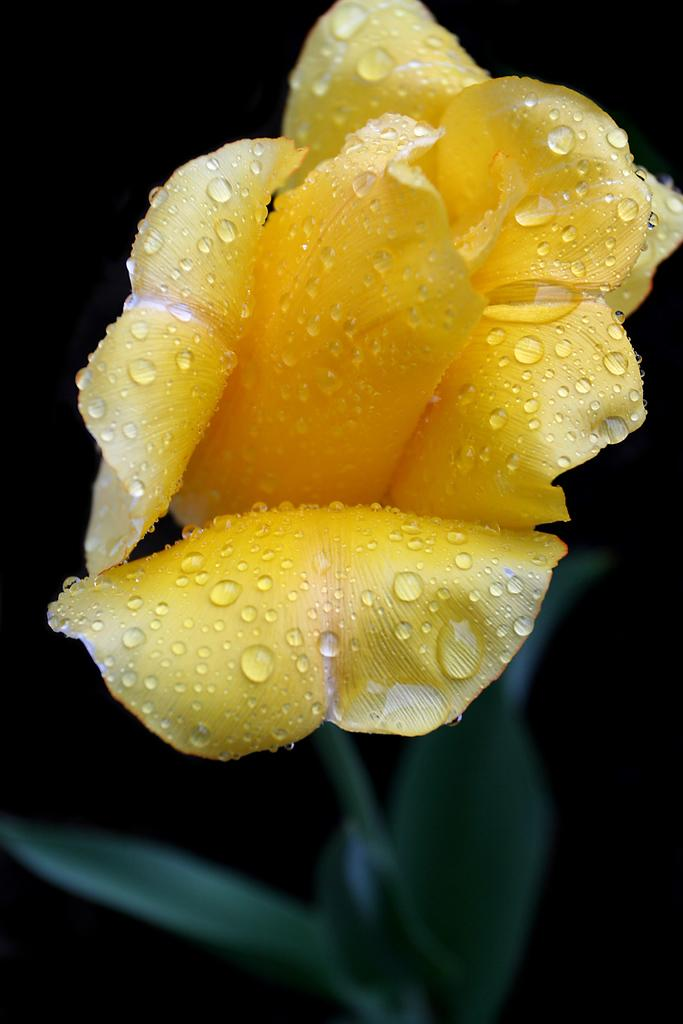What type of living organism is present in the image? There is a plant in the image. What features does the plant have? The plant has a flower and leaves. What color is the flower on the plant? The flower is yellow. What type of alarm can be heard going off in the image? There is no alarm present in the image; it is a picture of a plant with a yellow flower and leaves. How many screws are visible in the image? There are no screws present in the image; it is a picture of a plant with a yellow flower and leaves. 